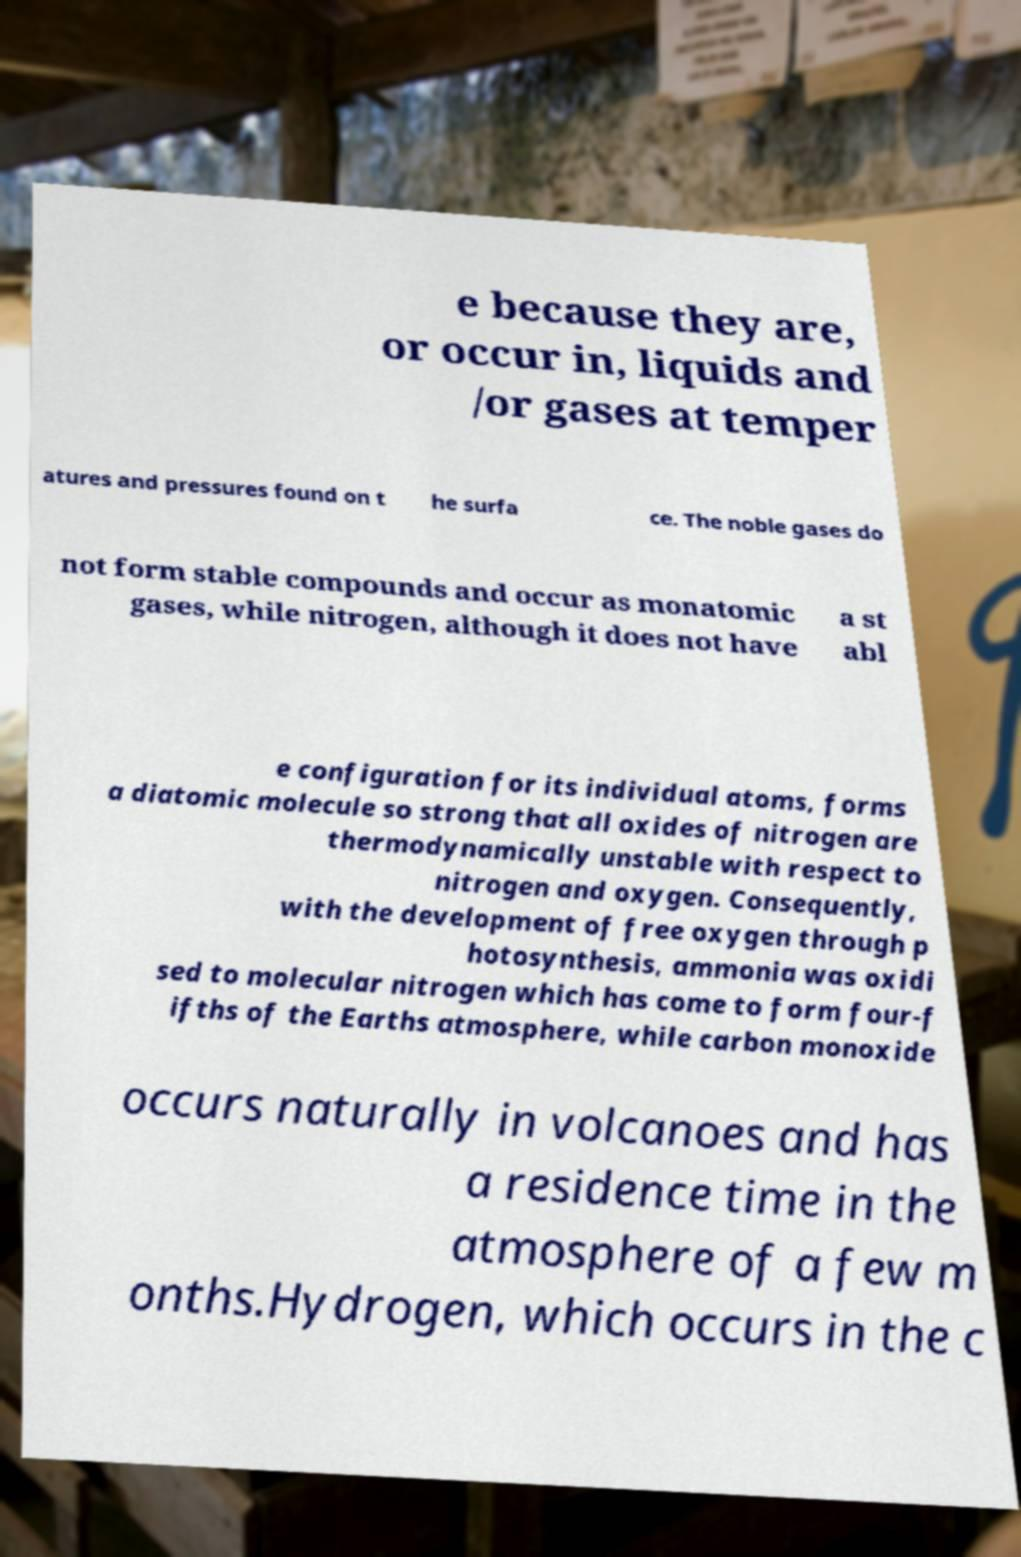Can you read and provide the text displayed in the image?This photo seems to have some interesting text. Can you extract and type it out for me? e because they are, or occur in, liquids and /or gases at temper atures and pressures found on t he surfa ce. The noble gases do not form stable compounds and occur as monatomic gases, while nitrogen, although it does not have a st abl e configuration for its individual atoms, forms a diatomic molecule so strong that all oxides of nitrogen are thermodynamically unstable with respect to nitrogen and oxygen. Consequently, with the development of free oxygen through p hotosynthesis, ammonia was oxidi sed to molecular nitrogen which has come to form four-f ifths of the Earths atmosphere, while carbon monoxide occurs naturally in volcanoes and has a residence time in the atmosphere of a few m onths.Hydrogen, which occurs in the c 